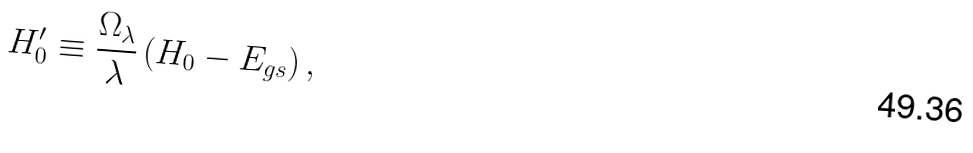Convert formula to latex. <formula><loc_0><loc_0><loc_500><loc_500>H ^ { \prime } _ { 0 } \equiv \frac { \Omega _ { \lambda } } { \lambda } \left ( H _ { 0 } - E _ { g s } \right ) ,</formula> 